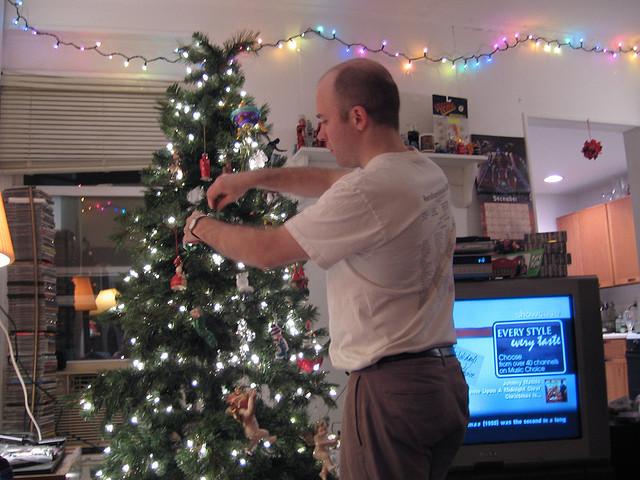What is on the television?
Keep it brief. Commercial. What holiday is being celebrated?
Keep it brief. Christmas. How many Christmas tree he is decorating?
Quick response, please. 1. 